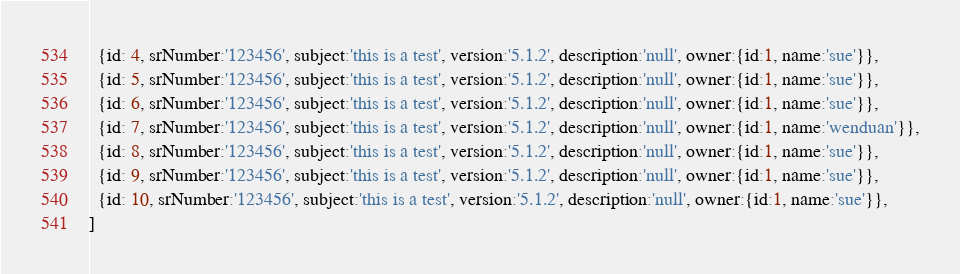<code> <loc_0><loc_0><loc_500><loc_500><_TypeScript_>  {id: 4, srNumber:'123456', subject:'this is a test', version:'5.1.2', description:'null', owner:{id:1, name:'sue'}},
  {id: 5, srNumber:'123456', subject:'this is a test', version:'5.1.2', description:'null', owner:{id:1, name:'sue'}},
  {id: 6, srNumber:'123456', subject:'this is a test', version:'5.1.2', description:'null', owner:{id:1, name:'sue'}},
  {id: 7, srNumber:'123456', subject:'this is a test', version:'5.1.2', description:'null', owner:{id:1, name:'wenduan'}},
  {id: 8, srNumber:'123456', subject:'this is a test', version:'5.1.2', description:'null', owner:{id:1, name:'sue'}},
  {id: 9, srNumber:'123456', subject:'this is a test', version:'5.1.2', description:'null', owner:{id:1, name:'sue'}},
  {id: 10, srNumber:'123456', subject:'this is a test', version:'5.1.2', description:'null', owner:{id:1, name:'sue'}},
]
</code> 